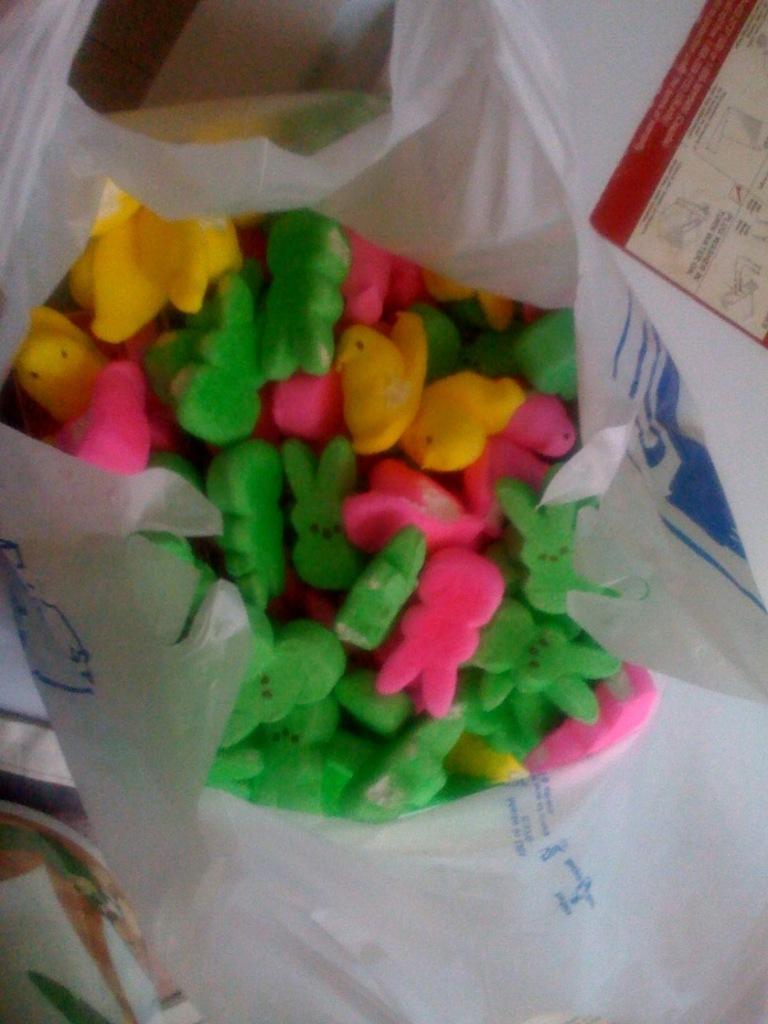Describe this image in one or two sentences. In this picture we can see some erasers of toy symbols and some are in duck symbol. This all are placed in a tissue paper and we can see a sticker over here and some cloth material. 